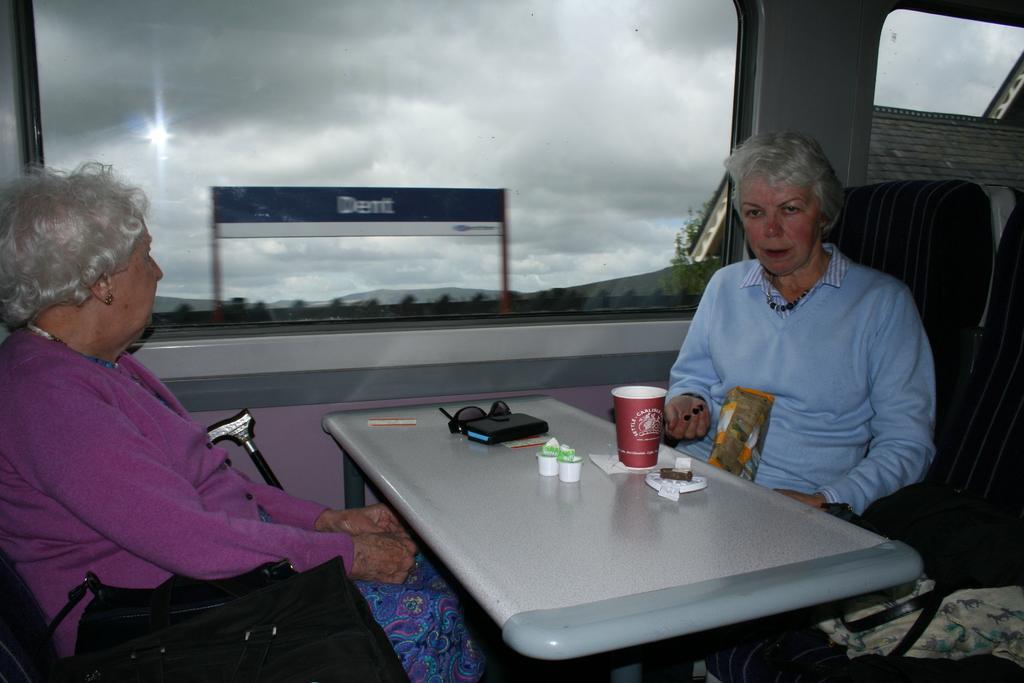How would you summarize this image in a sentence or two? This picture describes about two women are seated on the chair, in front of them we can find a cup, spectacles and a mobile on the table, the left side woman is seated on the chair, besides to her we can find a bag, in the background we can see a hoarding and couple of trees. 